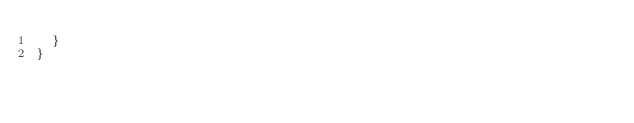<code> <loc_0><loc_0><loc_500><loc_500><_Kotlin_>  }
}
</code> 